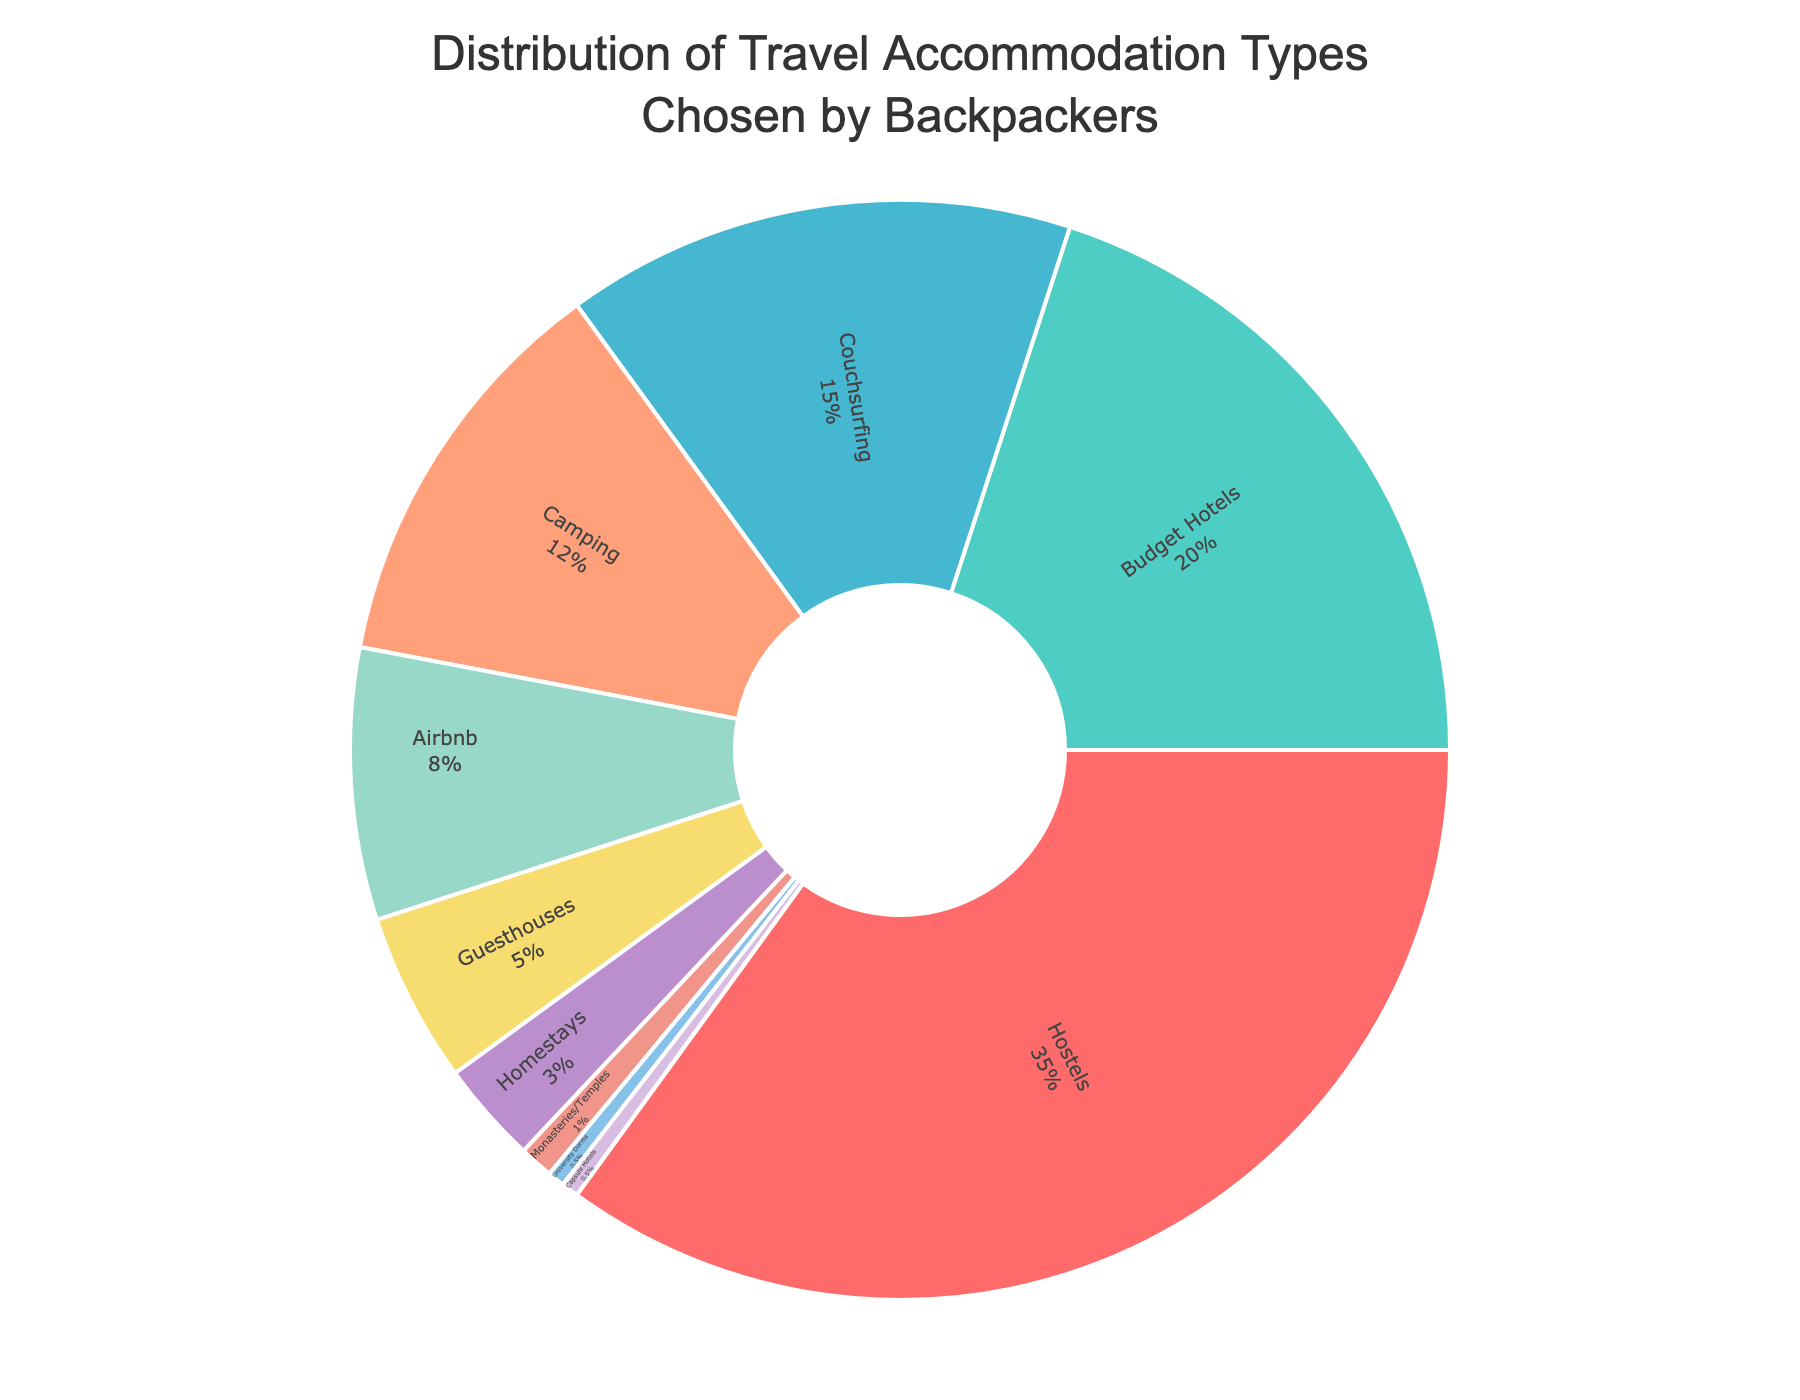Which accommodation type has the highest percentage? The accommodation types and their percentages are visually displayed in the pie chart. The largest sector of the pie chart is associated with Hostels.
Answer: Hostels What is the combined percentage of Budget Hotels and Couchsurfing? Simply add the percentage of Budget Hotels (20%) and Couchsurfing (15%). So, 20% + 15% = 35%.
Answer: 35% Which two accommodation types together make up less than 2% of the chart? Identify the accommodation types with the smallest percentages on the chart: Monasteries/Temples (1%) and University Dorms (0.5%) or University Dorms (0.5%) and Capsule Hotels (0.5%). Adding these pairs gives 1% + 0.5% = 1.5% or 0.5% + 0.5% = 1%.
Answer: University Dorms and Capsule Hotels (1%) How much larger is the percentage of Hostels compared to the percentage of Camping? Compare the percentages of Hostels (35%) and Camping (12%). Subtract the smaller from the larger: 35% - 12% = 23%.
Answer: 23% Which accommodation type is indicated with the color green in the pie chart? Identify the sectors of the pie chart by their colors: the green sector corresponds to Budget Hotels.
Answer: Budget Hotels What are the total percentages of Camping, Airbnb, and Guesthouses? Add the percentages for Camping (12%), Airbnb (8%), and Guesthouses (5%). So, 12% + 8% + 5% = 25%.
Answer: 25% Which accommodation type makes up less than 10% but more than 5% of the total? Examine the percentages visually and numerically, finding that Airbnb has 8%, which fits the criteria.
Answer: Airbnb What’s the difference in percentage between Couchsurfing and Guesthouses? Subtract the percentage of Guesthouses (5%) from Couchsurfing (15%): 15% - 5% = 10%.
Answer: 10% How many accommodation types have a percentage greater than 10%? Visually identify all sectors and count those with a percentage greater than 10%: Hostels (35%), Budget Hotels (20%), Couchsurfing (15%), and Camping (12%).
Answer: Four Which accommodation types are represented with blue shades, and what is their combined percentage? Identify the blue sectors as Couchsurfing (15%) and Capsule Hotels (0.5%) and add their percentages: 15% + 0.5% = 15.5%.
Answer: Couchsurfing and Capsule Hotels, 15.5% 